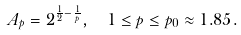<formula> <loc_0><loc_0><loc_500><loc_500>A _ { p } = 2 ^ { \frac { 1 } { 2 } - \frac { 1 } { p } } , \ \ 1 \leq p \leq p _ { 0 } \approx 1 . 8 5 .</formula> 